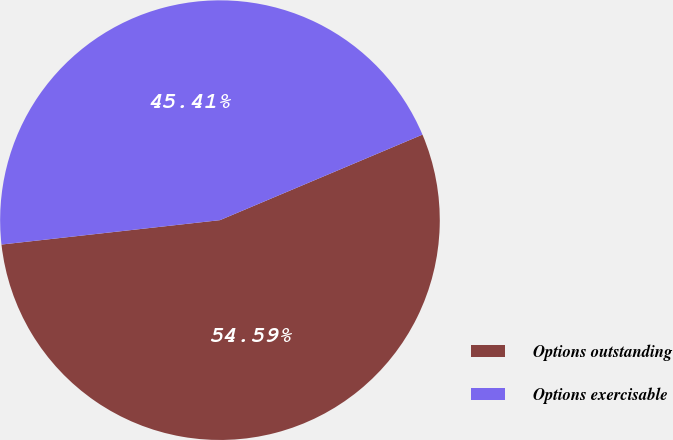Convert chart to OTSL. <chart><loc_0><loc_0><loc_500><loc_500><pie_chart><fcel>Options outstanding<fcel>Options exercisable<nl><fcel>54.59%<fcel>45.41%<nl></chart> 